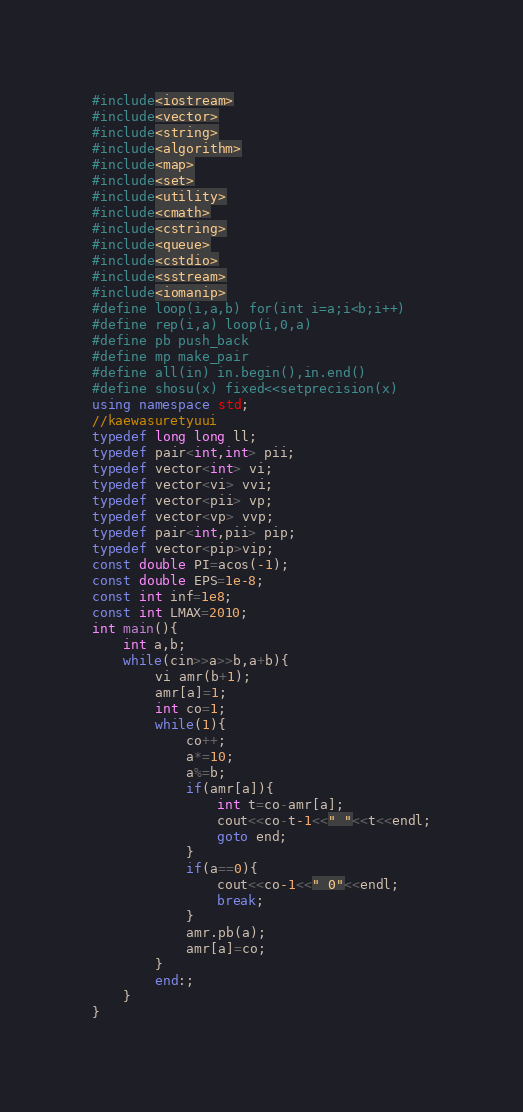<code> <loc_0><loc_0><loc_500><loc_500><_C++_>#include<iostream>
#include<vector>
#include<string>
#include<algorithm>	
#include<map>
#include<set>
#include<utility>
#include<cmath>
#include<cstring>
#include<queue>
#include<cstdio>
#include<sstream>
#include<iomanip>
#define loop(i,a,b) for(int i=a;i<b;i++) 
#define rep(i,a) loop(i,0,a)
#define pb push_back
#define mp make_pair
#define all(in) in.begin(),in.end()
#define shosu(x) fixed<<setprecision(x)
using namespace std;
//kaewasuretyuui
typedef long long ll;
typedef pair<int,int> pii;
typedef vector<int> vi;
typedef vector<vi> vvi;
typedef vector<pii> vp;
typedef vector<vp> vvp;
typedef pair<int,pii> pip;
typedef vector<pip>vip;
const double PI=acos(-1);
const double EPS=1e-8;
const int inf=1e8;
const int LMAX=2010;
int main(){
	int a,b;
	while(cin>>a>>b,a+b){
		vi amr(b+1);
		amr[a]=1;
		int co=1;
		while(1){
			co++;
			a*=10;
			a%=b;
			if(amr[a]){
				int t=co-amr[a];
				cout<<co-t-1<<" "<<t<<endl;
				goto end;
			}
			if(a==0){
				cout<<co-1<<" 0"<<endl;
				break;
			}
			amr.pb(a);
			amr[a]=co;
		}
		end:;
	}
}</code> 